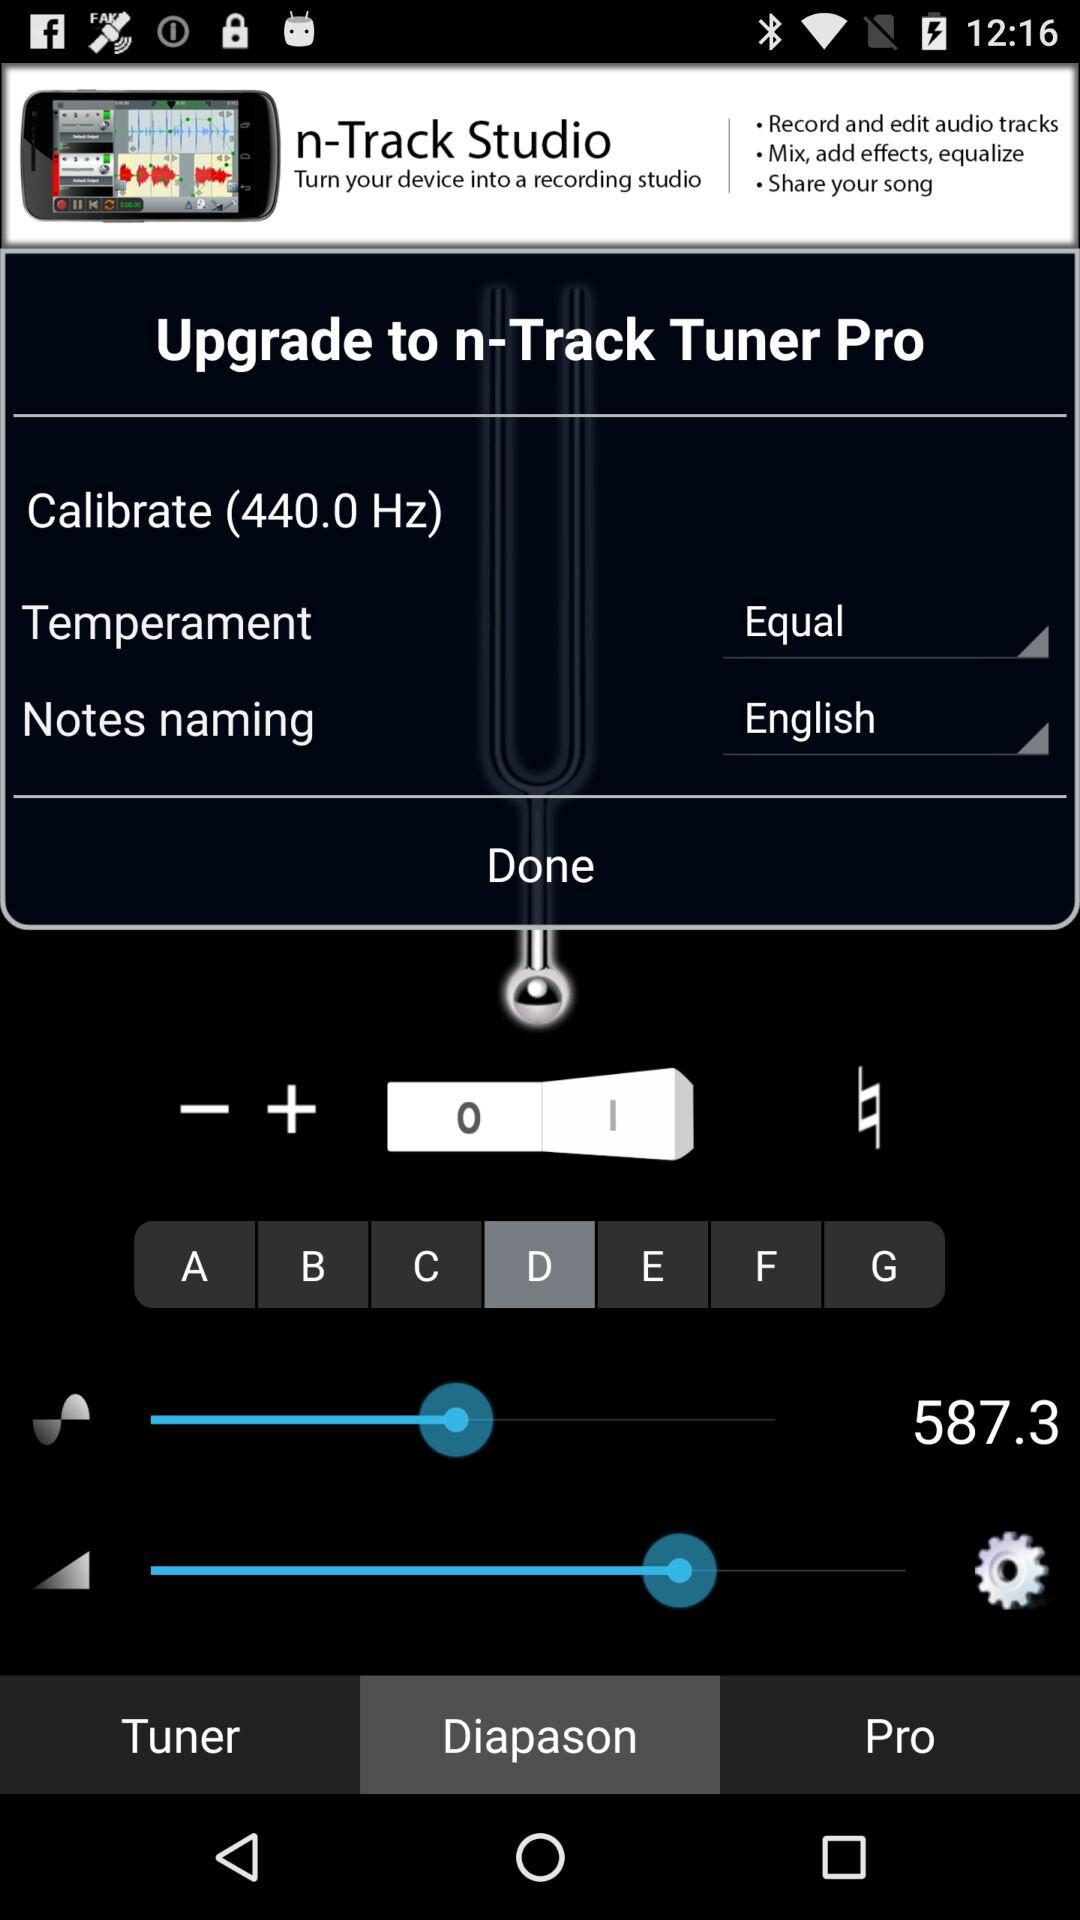What are the selected notes naming? The selected notes naming is "English". 